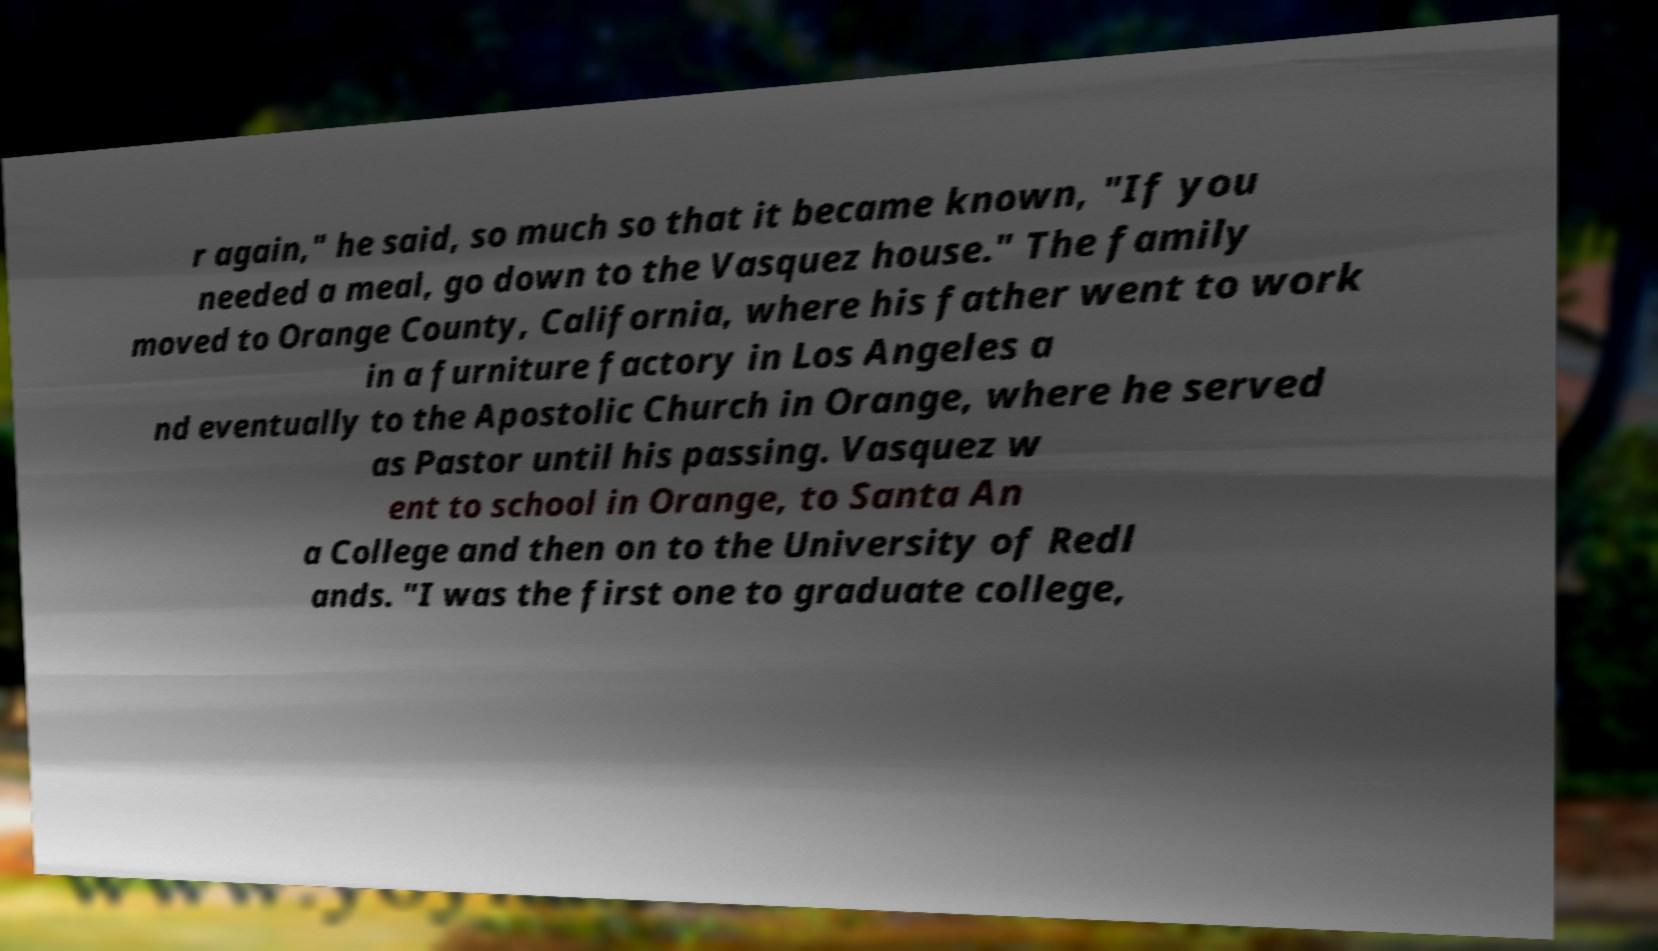There's text embedded in this image that I need extracted. Can you transcribe it verbatim? r again," he said, so much so that it became known, "If you needed a meal, go down to the Vasquez house." The family moved to Orange County, California, where his father went to work in a furniture factory in Los Angeles a nd eventually to the Apostolic Church in Orange, where he served as Pastor until his passing. Vasquez w ent to school in Orange, to Santa An a College and then on to the University of Redl ands. "I was the first one to graduate college, 